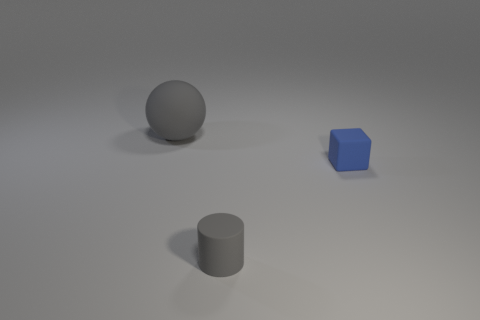Add 2 small rubber objects. How many objects exist? 5 Subtract all spheres. How many objects are left? 2 Add 2 tiny blocks. How many tiny blocks exist? 3 Subtract 0 cyan cylinders. How many objects are left? 3 Subtract all small blue rubber blocks. Subtract all red cubes. How many objects are left? 2 Add 3 small things. How many small things are left? 5 